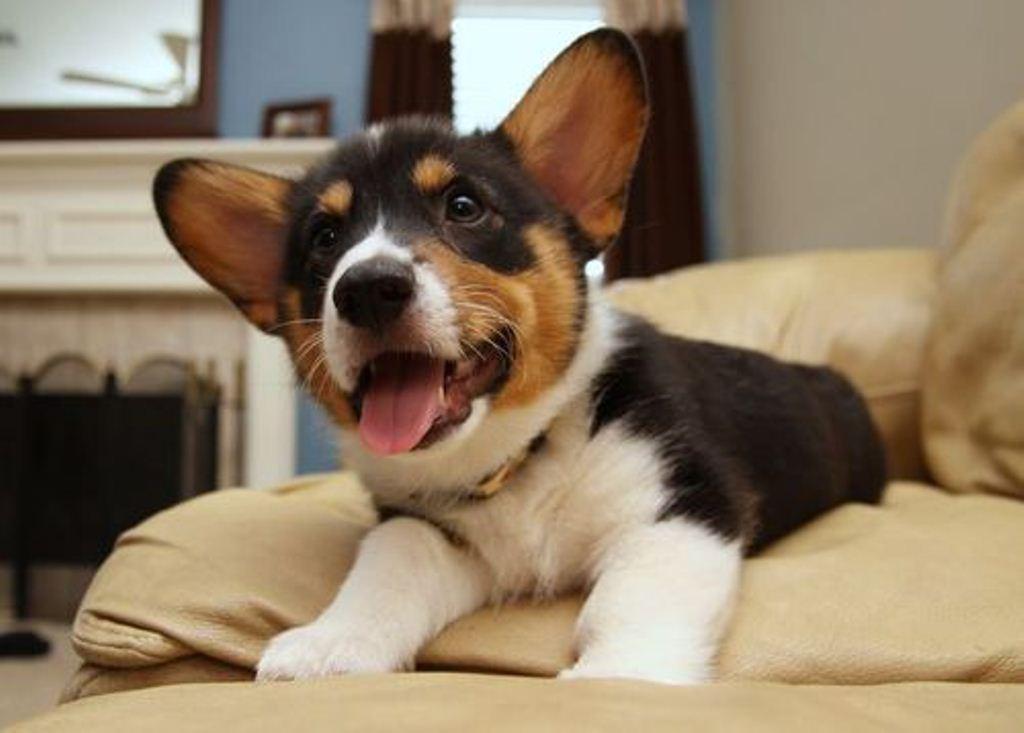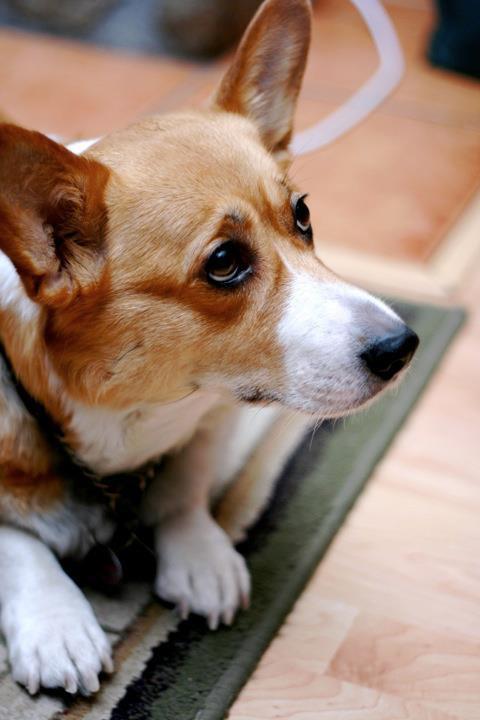The first image is the image on the left, the second image is the image on the right. Assess this claim about the two images: "At least one Corgi is behind a container of food.". Correct or not? Answer yes or no. No. The first image is the image on the left, the second image is the image on the right. Evaluate the accuracy of this statement regarding the images: "There us food in front of a single dog in at least one of the images.". Is it true? Answer yes or no. No. 